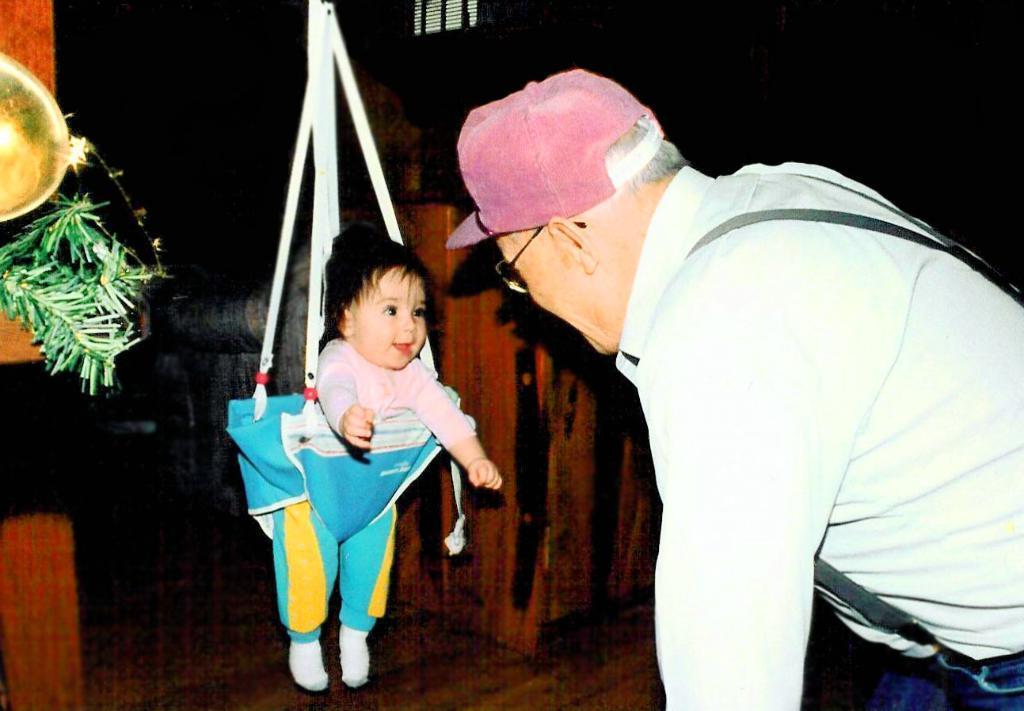Describe this image in one or two sentences. A man is standing at the right wearing a white shirt and suspenders. A baby is present on a bouncer swing. 